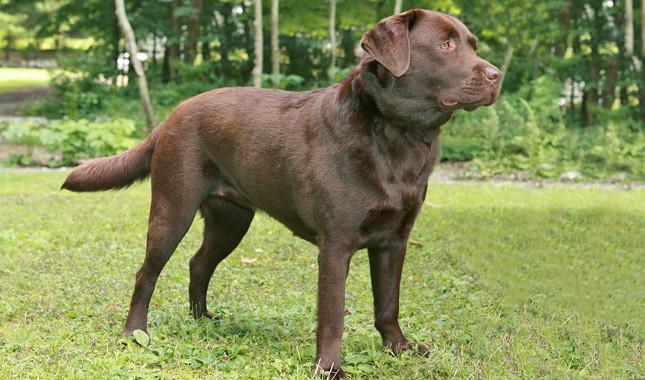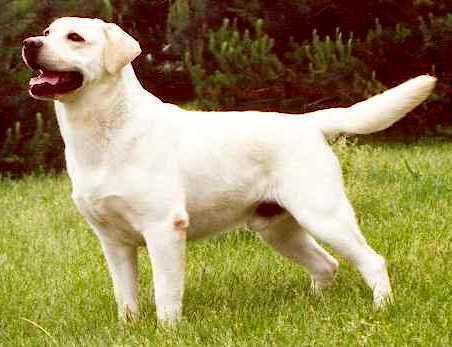The first image is the image on the left, the second image is the image on the right. For the images displayed, is the sentence "Images show foreground dogs in profile on grass with bodies in opposite directions." factually correct? Answer yes or no. Yes. 